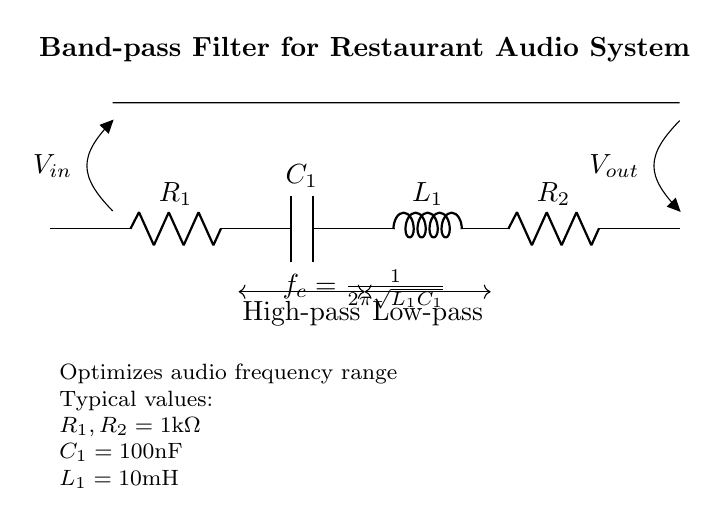What is the type of filter depicted in the circuit? The circuit diagram represents a band-pass filter, which is designed to allow a specific range of frequencies to pass while attenuating frequencies outside this range. This is visually indicated by the labeling and general structure of the components used.
Answer: Band-pass filter What is the value of the capacitor in the circuit? The circuit clearly shows a label next to the capacitor, indicating its value. It is marked as one hundred nanoFarads, which represents the capacitance of the component closely associated with the filter's functionality.
Answer: 100 nanoFarads What are the resistor values in the circuit? The circuit features two resistors, both labeled with the same value. This consistent identification allows for an easy reference to their value, which is indicated as one kilo-ohm each.
Answer: 1 kilo-ohm How is the cutoff frequency calculated in this circuit? The cutoff frequency in a band-pass filter is determined by the formula provided below the components. Specifically, it involves the inductor and capacitor values in a square root function, which defines the frequency at which the filter will begin to affect the signal.
Answer: 1/(2π√(L1C1)) What is the function of the inductor in the circuit? The inductor in this circuit serves to block high-frequency signals while allowing lower frequencies to pass, which is essential for the operation of a band-pass filter. The presence and value of the inductor help shape the desired frequency response of the audio system.
Answer: Blocks high frequencies What is indicated by the symbols “V in” and “V out”? These symbols represent the input and output voltages for the filter. Specifically, “V in” refers to the voltage input into the band-pass filter while “V out” represents the voltage output after the filtering process, showing how the filter modifies the input signal.
Answer: Input and output voltages 